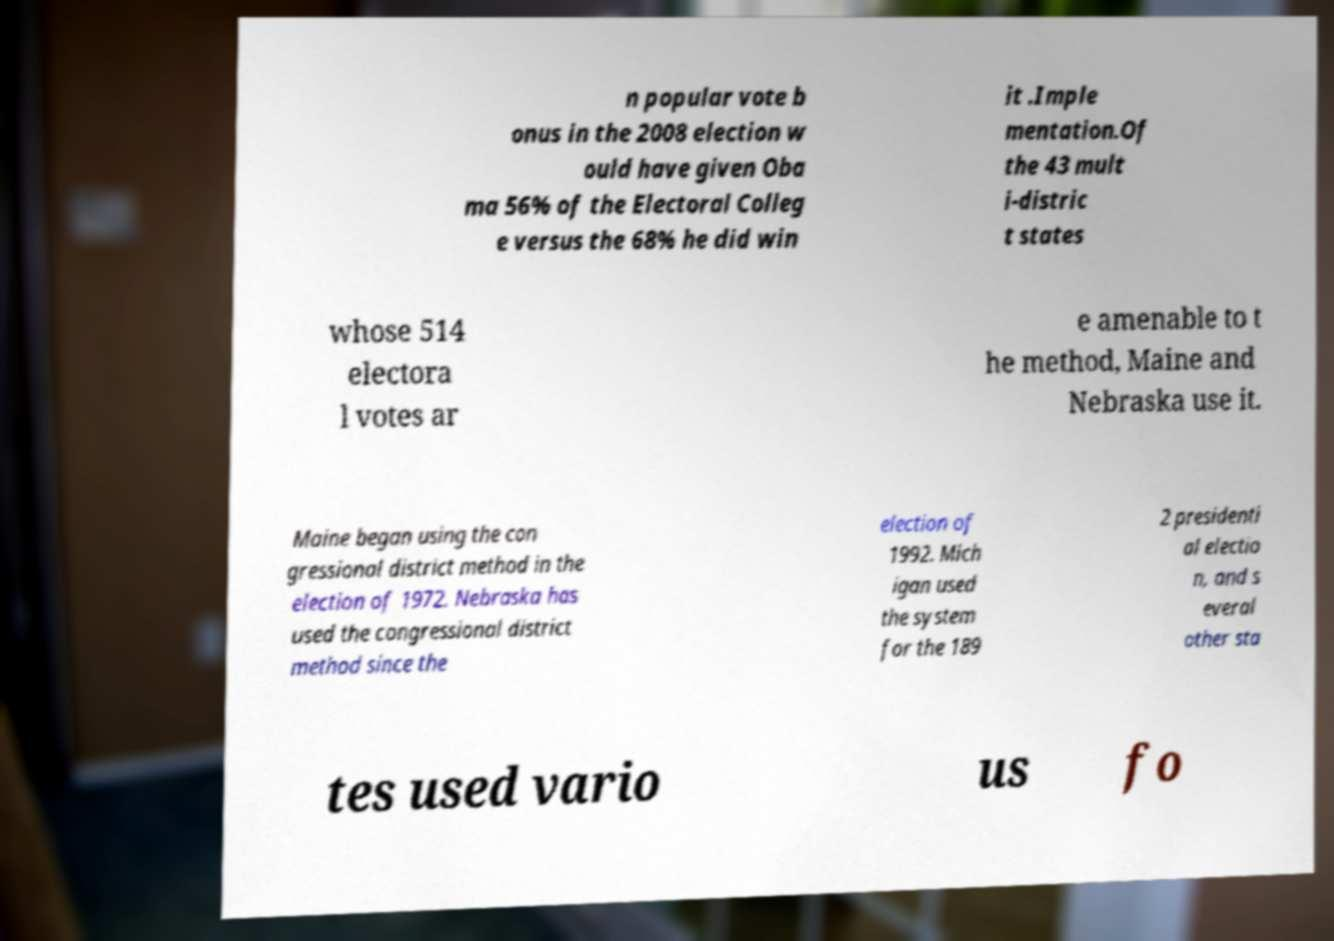There's text embedded in this image that I need extracted. Can you transcribe it verbatim? n popular vote b onus in the 2008 election w ould have given Oba ma 56% of the Electoral Colleg e versus the 68% he did win it .Imple mentation.Of the 43 mult i-distric t states whose 514 electora l votes ar e amenable to t he method, Maine and Nebraska use it. Maine began using the con gressional district method in the election of 1972. Nebraska has used the congressional district method since the election of 1992. Mich igan used the system for the 189 2 presidenti al electio n, and s everal other sta tes used vario us fo 